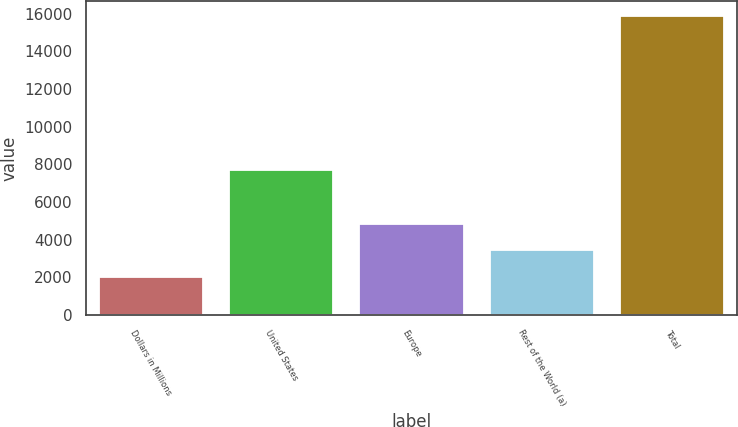Convert chart to OTSL. <chart><loc_0><loc_0><loc_500><loc_500><bar_chart><fcel>Dollars in Millions<fcel>United States<fcel>Europe<fcel>Rest of the World (a)<fcel>Total<nl><fcel>2014<fcel>7716<fcel>4845.5<fcel>3459<fcel>15879<nl></chart> 